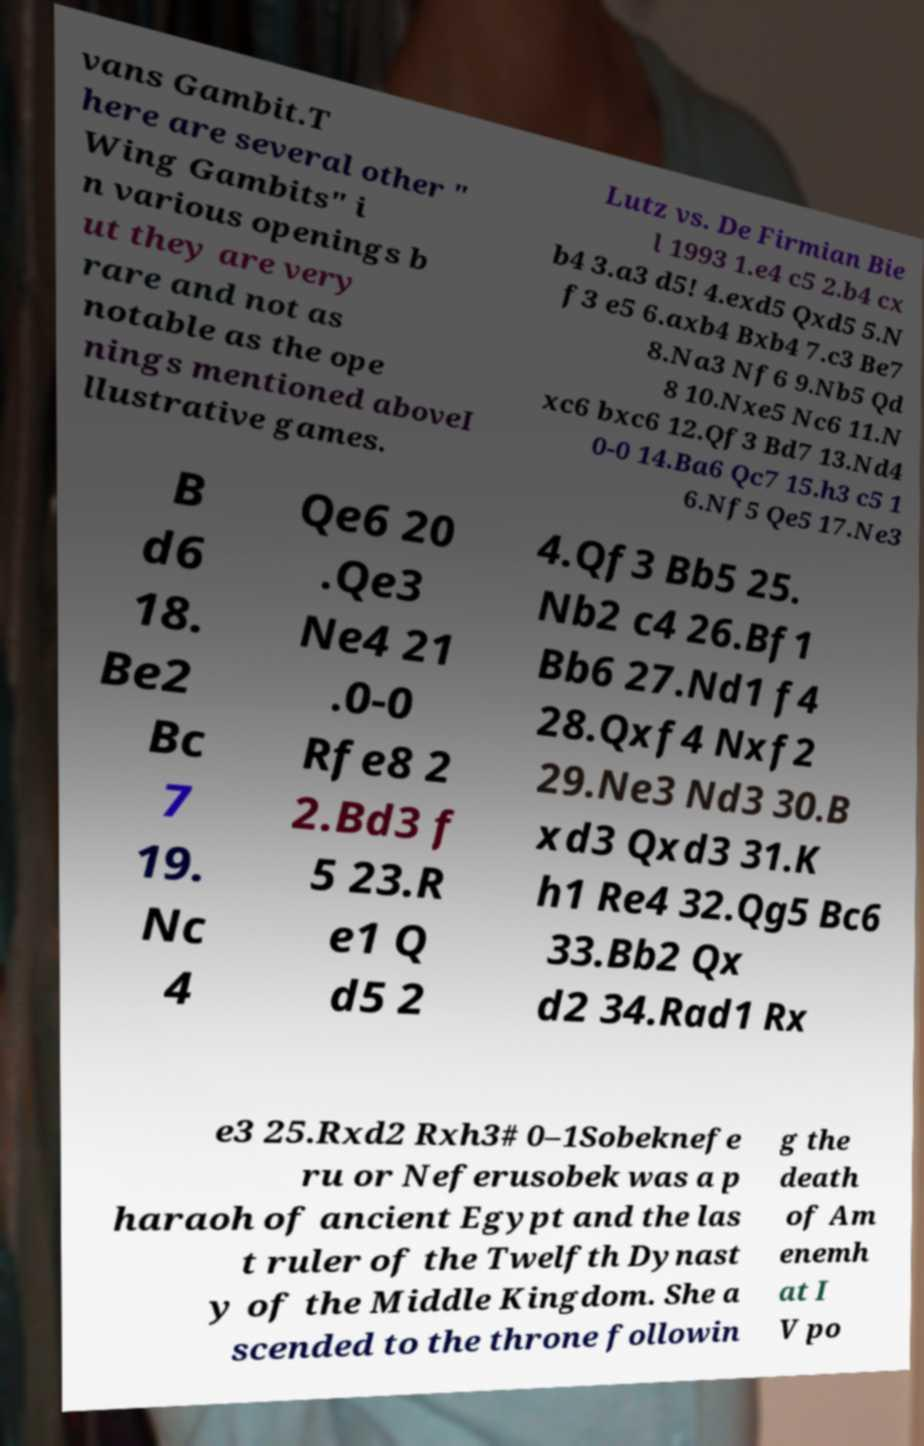I need the written content from this picture converted into text. Can you do that? vans Gambit.T here are several other " Wing Gambits" i n various openings b ut they are very rare and not as notable as the ope nings mentioned aboveI llustrative games. Lutz vs. De Firmian Bie l 1993 1.e4 c5 2.b4 cx b4 3.a3 d5! 4.exd5 Qxd5 5.N f3 e5 6.axb4 Bxb4 7.c3 Be7 8.Na3 Nf6 9.Nb5 Qd 8 10.Nxe5 Nc6 11.N xc6 bxc6 12.Qf3 Bd7 13.Nd4 0-0 14.Ba6 Qc7 15.h3 c5 1 6.Nf5 Qe5 17.Ne3 B d6 18. Be2 Bc 7 19. Nc 4 Qe6 20 .Qe3 Ne4 21 .0-0 Rfe8 2 2.Bd3 f 5 23.R e1 Q d5 2 4.Qf3 Bb5 25. Nb2 c4 26.Bf1 Bb6 27.Nd1 f4 28.Qxf4 Nxf2 29.Ne3 Nd3 30.B xd3 Qxd3 31.K h1 Re4 32.Qg5 Bc6 33.Bb2 Qx d2 34.Rad1 Rx e3 25.Rxd2 Rxh3# 0–1Sobeknefe ru or Neferusobek was a p haraoh of ancient Egypt and the las t ruler of the Twelfth Dynast y of the Middle Kingdom. She a scended to the throne followin g the death of Am enemh at I V po 